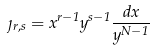<formula> <loc_0><loc_0><loc_500><loc_500>\eta _ { r , s } = x ^ { r - 1 } y ^ { s - 1 } \frac { d x } { y ^ { N - 1 } }</formula> 